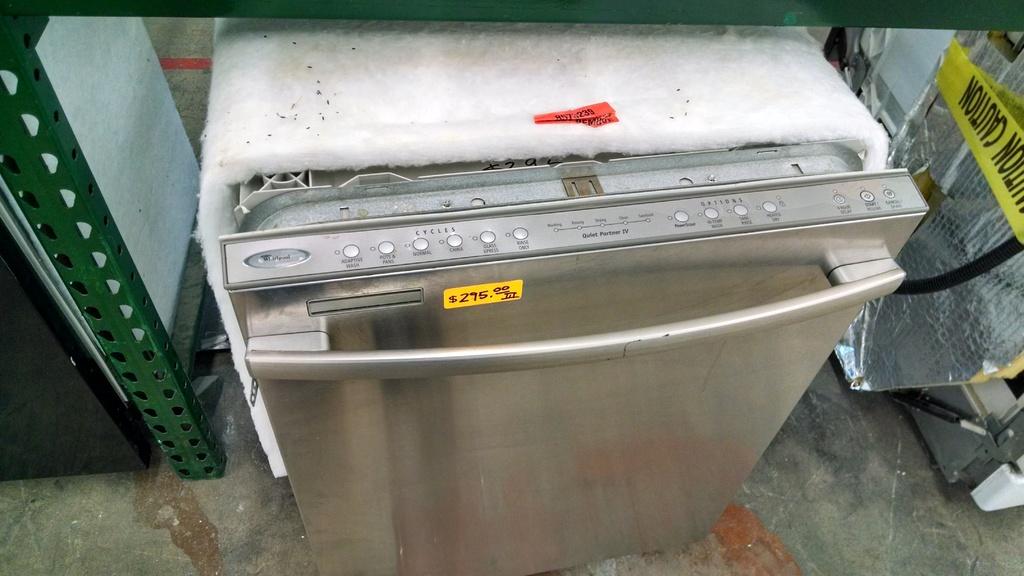At what price is the refrigerator retailing?
Your response must be concise. Unanswerable. What does the yellow tape to the very right say on it?
Ensure brevity in your answer.  Caution. 